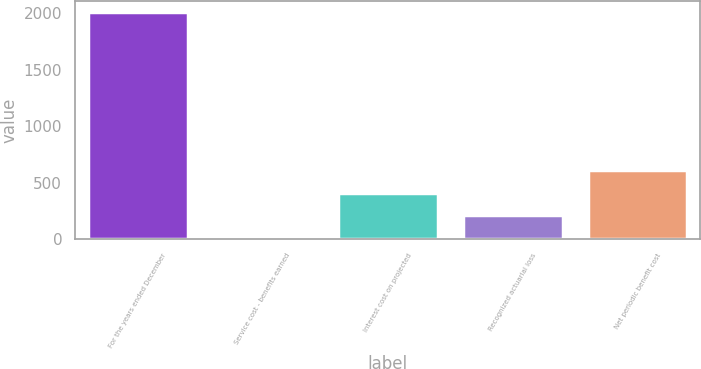Convert chart. <chart><loc_0><loc_0><loc_500><loc_500><bar_chart><fcel>For the years ended December<fcel>Service cost - benefits earned<fcel>Interest cost on projected<fcel>Recognized actuarial loss<fcel>Net periodic benefit cost<nl><fcel>2012<fcel>13<fcel>412.8<fcel>212.9<fcel>612.7<nl></chart> 